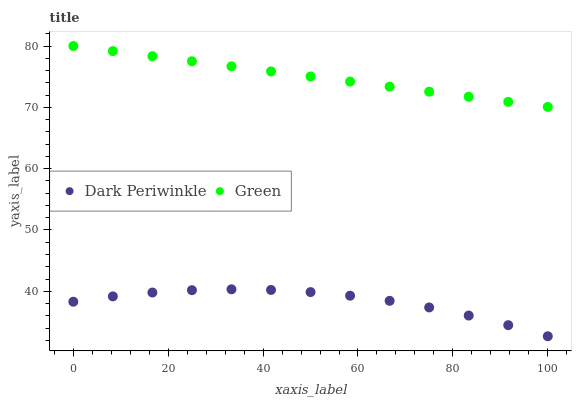Does Dark Periwinkle have the minimum area under the curve?
Answer yes or no. Yes. Does Green have the maximum area under the curve?
Answer yes or no. Yes. Does Dark Periwinkle have the maximum area under the curve?
Answer yes or no. No. Is Green the smoothest?
Answer yes or no. Yes. Is Dark Periwinkle the roughest?
Answer yes or no. Yes. Is Dark Periwinkle the smoothest?
Answer yes or no. No. Does Dark Periwinkle have the lowest value?
Answer yes or no. Yes. Does Green have the highest value?
Answer yes or no. Yes. Does Dark Periwinkle have the highest value?
Answer yes or no. No. Is Dark Periwinkle less than Green?
Answer yes or no. Yes. Is Green greater than Dark Periwinkle?
Answer yes or no. Yes. Does Dark Periwinkle intersect Green?
Answer yes or no. No. 